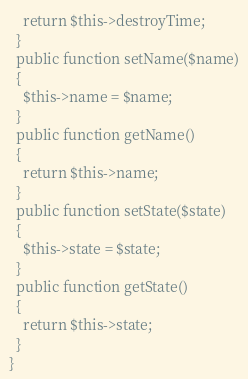<code> <loc_0><loc_0><loc_500><loc_500><_PHP_>    return $this->destroyTime;
  }
  public function setName($name)
  {
    $this->name = $name;
  }
  public function getName()
  {
    return $this->name;
  }
  public function setState($state)
  {
    $this->state = $state;
  }
  public function getState()
  {
    return $this->state;
  }
}
</code> 